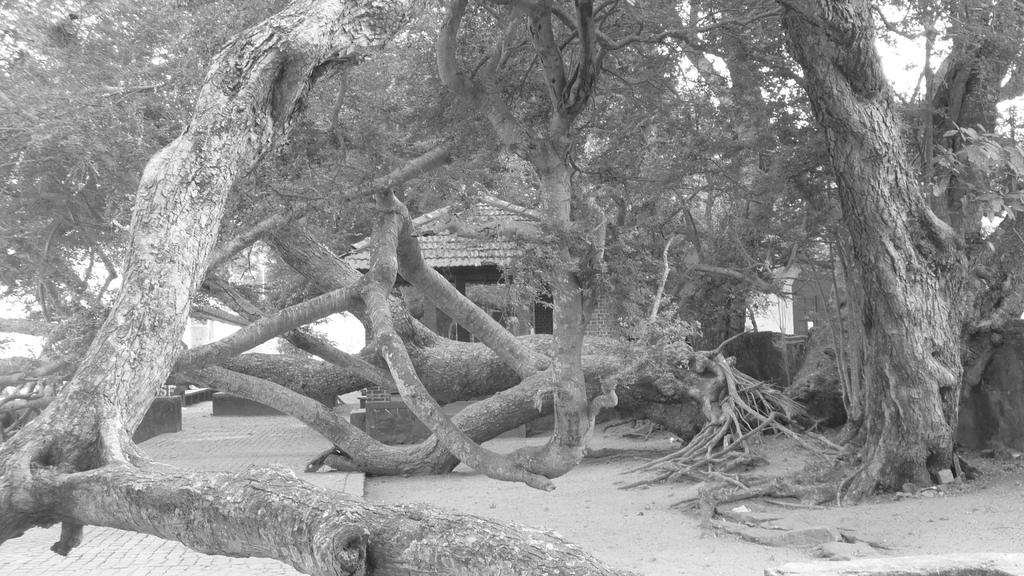What type of natural vegetation is present in the image? There are trees in the image. What type of man-made structures can be seen in the image? There are houses in the image. What objects are present that are made of wood? There are trunks in the image. What color scheme is used in the image? The image is in black and white. What is the name of the cable company that provides service to the houses in the image? There is no information about cable companies or their names in the image. How many pins are visible on the trunks in the image? There are no pins present on the trunks in the image. 